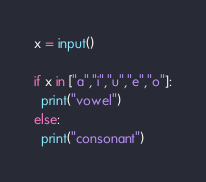Convert code to text. <code><loc_0><loc_0><loc_500><loc_500><_Python_>x = input()

if x in ["a","i","u","e","o"]:
  print("vowel")
else:
  print("consonant")
</code> 